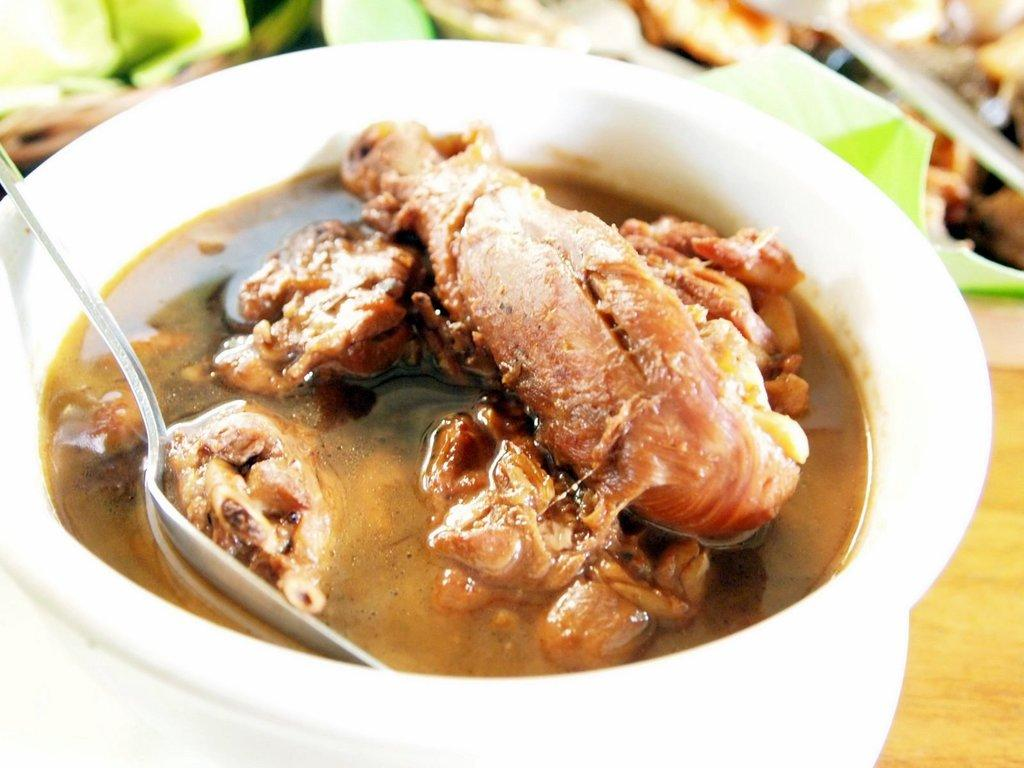What utensil can be seen in the image? There is a spoon in the image. What is the color of the bowl containing the food item? The bowl is white. What type of surface is the bowl placed on? The bowl is placed on a wooden surface. Can you describe any other objects visible in the background of the image? Unfortunately, the provided facts do not give any information about other objects in the background. Is the river flowing in the background of the image? There is no river present in the image. 